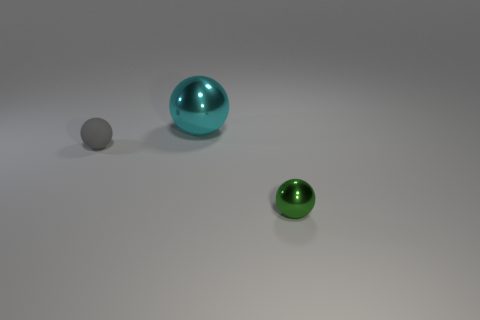Subtract all tiny balls. How many balls are left? 1 Add 2 metal things. How many objects exist? 5 Add 1 large things. How many large things exist? 2 Subtract 0 gray blocks. How many objects are left? 3 Subtract all gray objects. Subtract all big brown metallic cylinders. How many objects are left? 2 Add 1 big metal spheres. How many big metal spheres are left? 2 